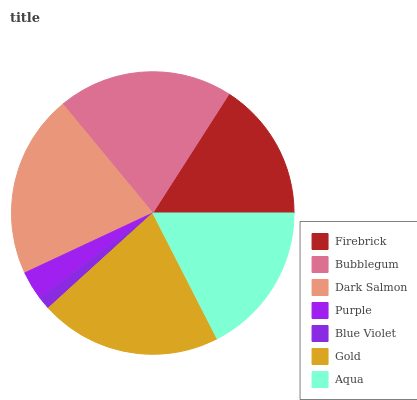Is Blue Violet the minimum?
Answer yes or no. Yes. Is Dark Salmon the maximum?
Answer yes or no. Yes. Is Bubblegum the minimum?
Answer yes or no. No. Is Bubblegum the maximum?
Answer yes or no. No. Is Bubblegum greater than Firebrick?
Answer yes or no. Yes. Is Firebrick less than Bubblegum?
Answer yes or no. Yes. Is Firebrick greater than Bubblegum?
Answer yes or no. No. Is Bubblegum less than Firebrick?
Answer yes or no. No. Is Aqua the high median?
Answer yes or no. Yes. Is Aqua the low median?
Answer yes or no. Yes. Is Purple the high median?
Answer yes or no. No. Is Purple the low median?
Answer yes or no. No. 